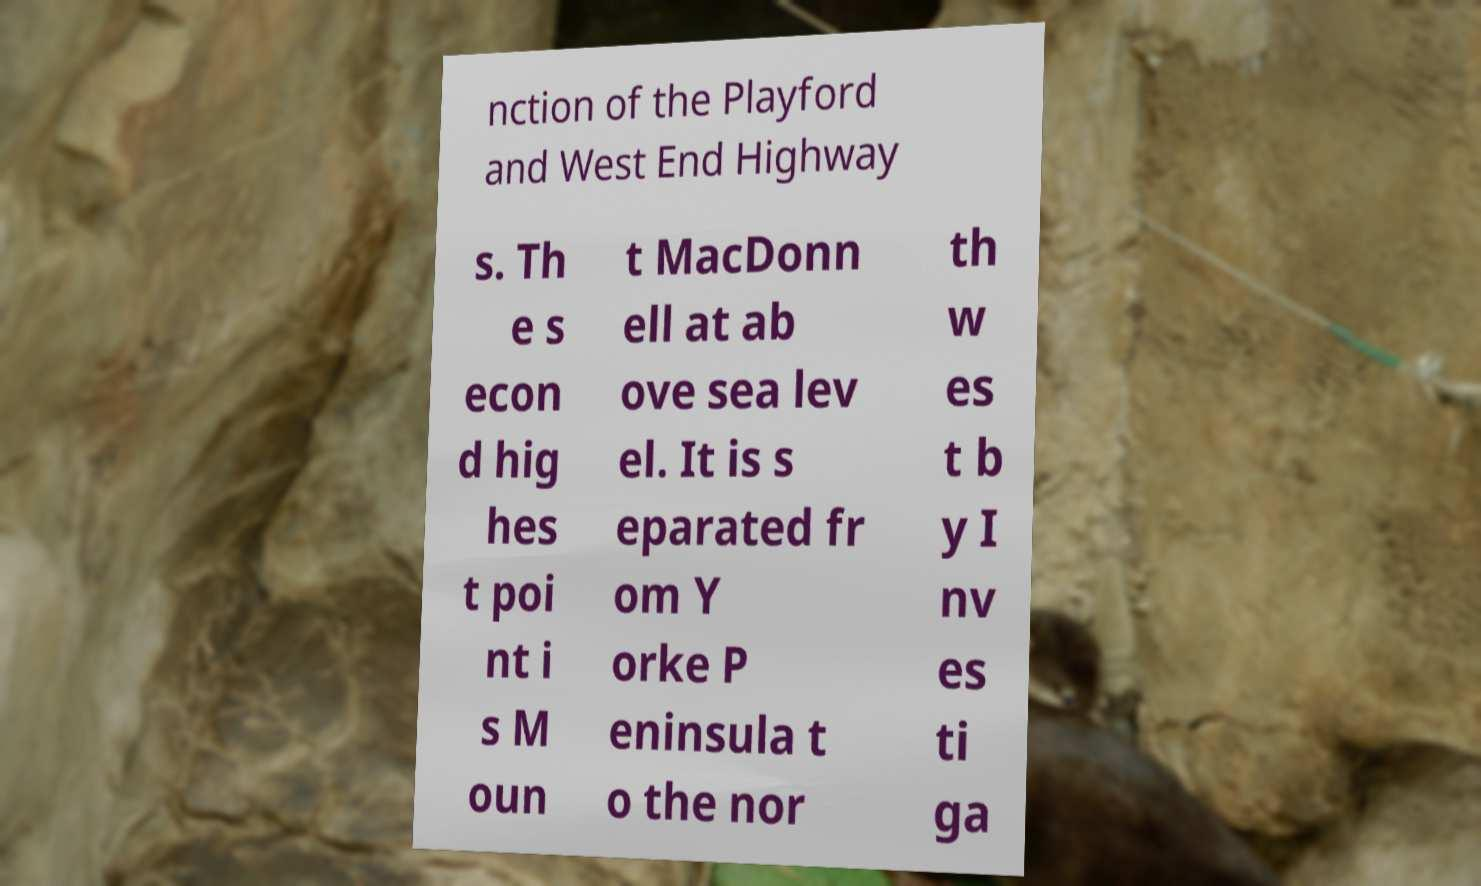For documentation purposes, I need the text within this image transcribed. Could you provide that? nction of the Playford and West End Highway s. Th e s econ d hig hes t poi nt i s M oun t MacDonn ell at ab ove sea lev el. It is s eparated fr om Y orke P eninsula t o the nor th w es t b y I nv es ti ga 